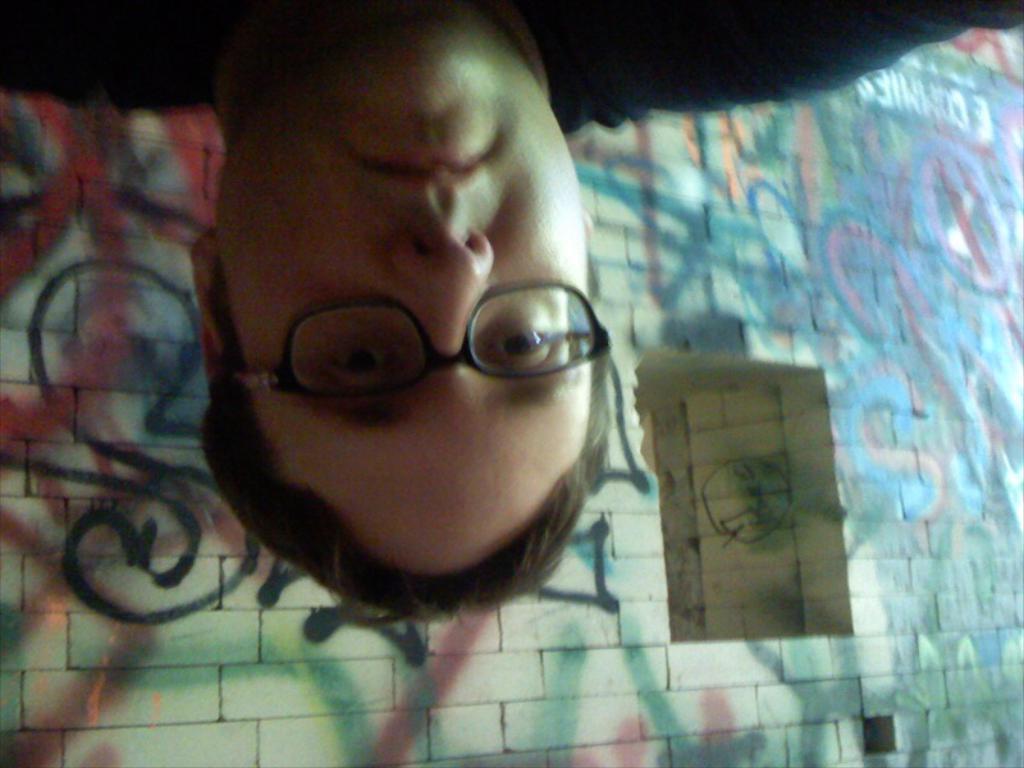Please provide a concise description of this image. In this image I can see a person, window and wall paintings on a wall. This image is taken may be during the night. 